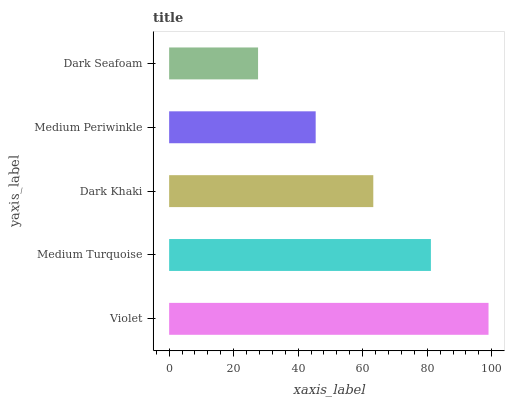Is Dark Seafoam the minimum?
Answer yes or no. Yes. Is Violet the maximum?
Answer yes or no. Yes. Is Medium Turquoise the minimum?
Answer yes or no. No. Is Medium Turquoise the maximum?
Answer yes or no. No. Is Violet greater than Medium Turquoise?
Answer yes or no. Yes. Is Medium Turquoise less than Violet?
Answer yes or no. Yes. Is Medium Turquoise greater than Violet?
Answer yes or no. No. Is Violet less than Medium Turquoise?
Answer yes or no. No. Is Dark Khaki the high median?
Answer yes or no. Yes. Is Dark Khaki the low median?
Answer yes or no. Yes. Is Medium Periwinkle the high median?
Answer yes or no. No. Is Medium Periwinkle the low median?
Answer yes or no. No. 